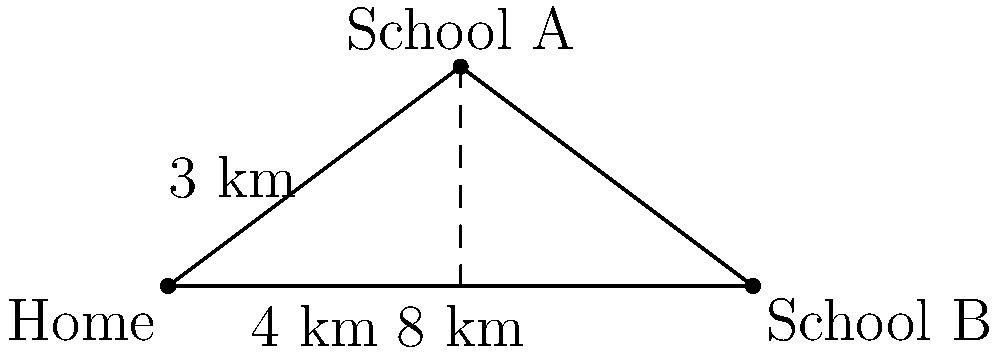As a protective parent, you want to determine the optimal walking distance for your children between home and their schools. Given the map above with distance markers, calculate the shortest walking distance from home to School A. Round your answer to the nearest tenth of a kilometer. To find the shortest walking distance from home to School A, we can use the Pythagorean theorem:

1) The map forms a right triangle with home at one corner and School A at another.
2) The base of the triangle is 4 km and the height is 3 km.
3) Let's call the hypotenuse $x$, which represents the shortest distance.
4) Using the Pythagorean theorem: $x^2 = 4^2 + 3^2$
5) Simplify: $x^2 = 16 + 9 = 25$
6) Take the square root of both sides: $x = \sqrt{25} = 5$

Therefore, the shortest walking distance from home to School A is 5 km.

As a protective parent, it's important to note that this is the direct distance and may not represent the actual walking route, which could be longer due to roads and paths.
Answer: 5.0 km 